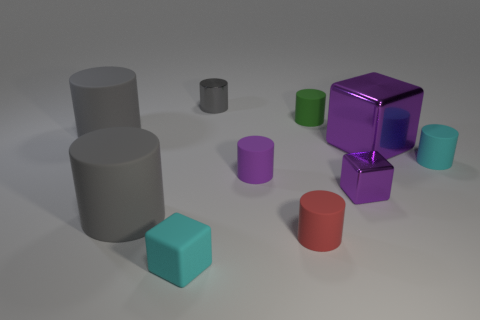Is the large shiny thing the same shape as the small purple shiny thing? Yes, both objects share the same geometric shape. They are both cubes, characterized by their six square faces, edges of equal length, and right-angled corners. 